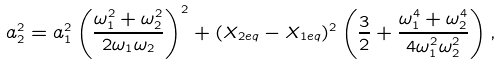<formula> <loc_0><loc_0><loc_500><loc_500>a ^ { 2 } _ { 2 } = a _ { 1 } ^ { 2 } \left ( \frac { \omega _ { 1 } ^ { 2 } + \omega _ { 2 } ^ { 2 } } { 2 \omega _ { 1 } \omega _ { 2 } } \right ) ^ { 2 } + ( X _ { 2 e q } - X _ { 1 e q } ) ^ { 2 } \left ( \frac { 3 } { 2 } + \frac { \omega _ { 1 } ^ { 4 } + \omega _ { 2 } ^ { 4 } } { 4 \omega _ { 1 } ^ { 2 } \omega _ { 2 } ^ { 2 } } \right ) ,</formula> 